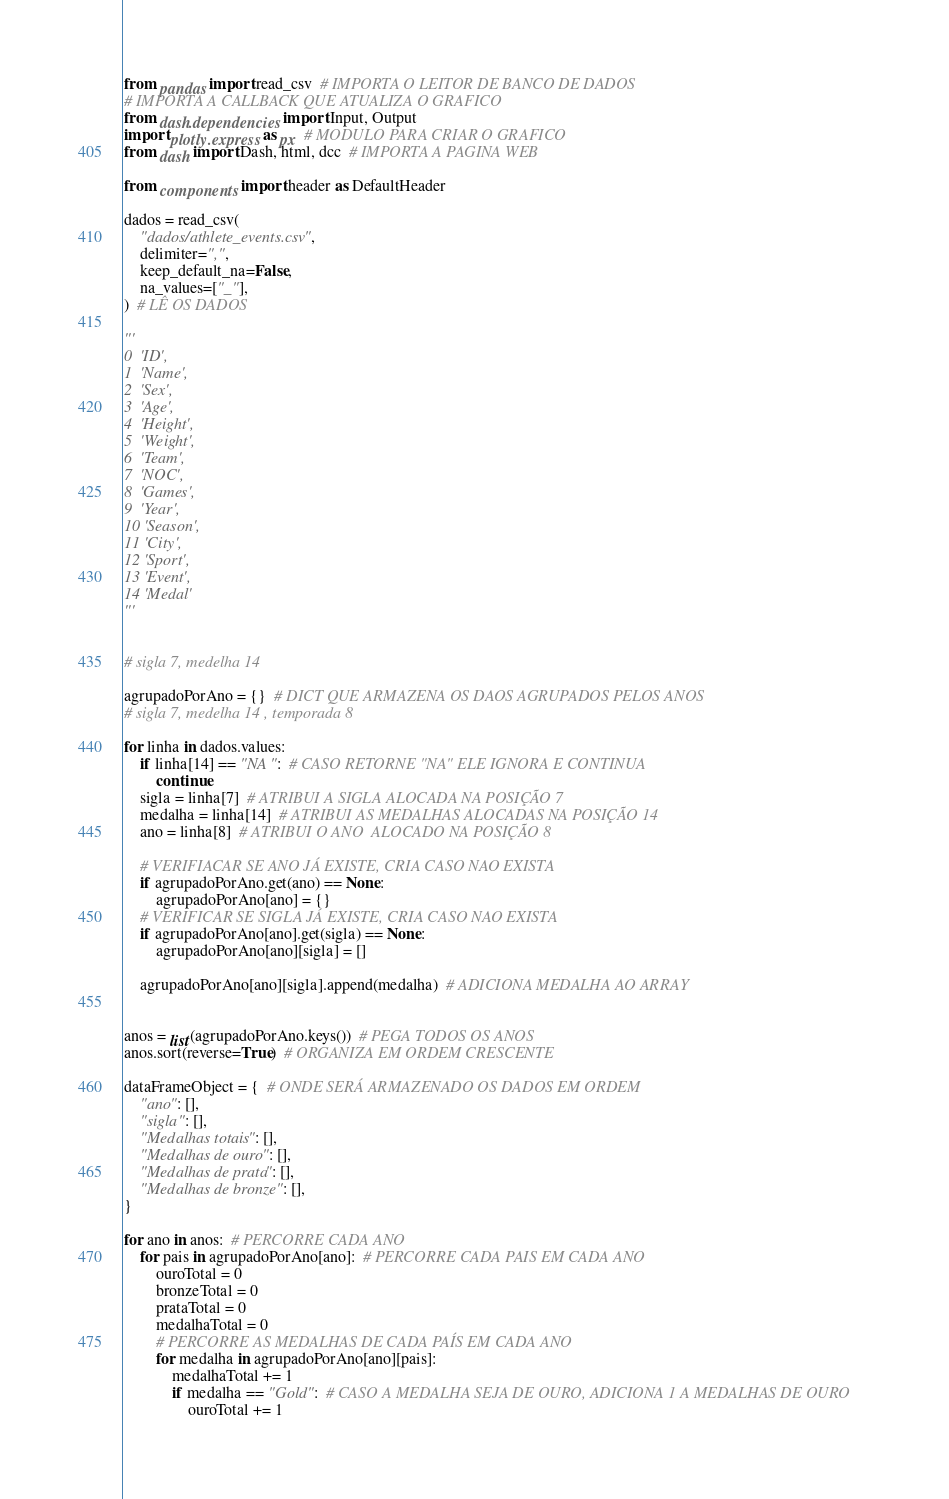<code> <loc_0><loc_0><loc_500><loc_500><_Python_>from pandas import read_csv  # IMPORTA O LEITOR DE BANCO DE DADOS
# IMPORTA A CALLBACK QUE ATUALIZA O GRAFICO
from dash.dependencies import Input, Output
import plotly.express as px  # MODULO PARA CRIAR O GRAFICO
from dash import Dash, html, dcc  # IMPORTA A PAGINA WEB

from components import header as DefaultHeader

dados = read_csv(
    "dados/athlete_events.csv",
    delimiter=",",
    keep_default_na=False,
    na_values=["_"],
)  # LÊ OS DADOS

'''
0  'ID',
1  'Name',
2  'Sex',
3  'Age',
4  'Height',
5  'Weight',
6  'Team',
7  'NOC',
8  'Games',
9  'Year',
10 'Season',
11 'City',
12 'Sport',
13 'Event',
14 'Medal'
'''


# sigla 7, medelha 14

agrupadoPorAno = {}  # DICT QUE ARMAZENA OS DAOS AGRUPADOS PELOS ANOS
# sigla 7, medelha 14 , temporada 8

for linha in dados.values:
    if linha[14] == "NA":  # CASO RETORNE "NA" ELE IGNORA E CONTINUA
        continue
    sigla = linha[7]  # ATRIBUI A SIGLA ALOCADA NA POSIÇÃO 7
    medalha = linha[14]  # ATRIBUI AS MEDALHAS ALOCADAS NA POSIÇÃO 14
    ano = linha[8]  # ATRIBUI O ANO  ALOCADO NA POSIÇÃO 8

    # VERIFIACAR SE ANO JÁ EXISTE, CRIA CASO NAO EXISTA
    if agrupadoPorAno.get(ano) == None:
        agrupadoPorAno[ano] = {}
    # VERIFICAR SE SIGLA JÁ EXISTE, CRIA CASO NAO EXISTA
    if agrupadoPorAno[ano].get(sigla) == None:
        agrupadoPorAno[ano][sigla] = []

    agrupadoPorAno[ano][sigla].append(medalha)  # ADICIONA MEDALHA AO ARRAY


anos = list(agrupadoPorAno.keys())  # PEGA TODOS OS ANOS
anos.sort(reverse=True)  # ORGANIZA EM ORDEM CRESCENTE

dataFrameObject = {  # ONDE SERÁ ARMAZENADO OS DADOS EM ORDEM
    "ano": [],
    "sigla": [],
    "Medalhas totais": [],
    "Medalhas de ouro": [],
    "Medalhas de prata": [],
    "Medalhas de bronze": [],
}

for ano in anos:  # PERCORRE CADA ANO
    for pais in agrupadoPorAno[ano]:  # PERCORRE CADA PAIS EM CADA ANO
        ouroTotal = 0
        bronzeTotal = 0
        prataTotal = 0
        medalhaTotal = 0
        # PERCORRE AS MEDALHAS DE CADA PAÍS EM CADA ANO
        for medalha in agrupadoPorAno[ano][pais]:
            medalhaTotal += 1
            if medalha == "Gold":  # CASO A MEDALHA SEJA DE OURO, ADICIONA 1 A MEDALHAS DE OURO
                ouroTotal += 1</code> 